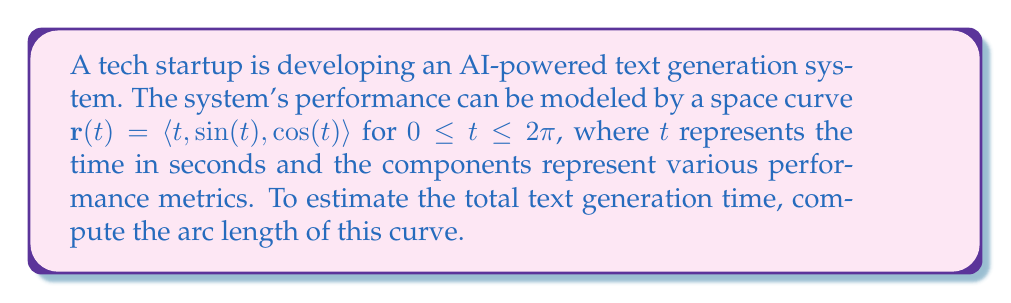Provide a solution to this math problem. To find the arc length of a space curve, we use the formula:

$$L = \int_a^b \sqrt{\left(\frac{dx}{dt}\right)^2 + \left(\frac{dy}{dt}\right)^2 + \left(\frac{dz}{dt}\right)^2} dt$$

Where $\mathbf{r}(t) = \langle x(t), y(t), z(t) \rangle$.

For our curve $\mathbf{r}(t) = \langle t, \sin(t), \cos(t) \rangle$:

1) First, we find the derivatives:
   $\frac{dx}{dt} = 1$
   $\frac{dy}{dt} = \cos(t)$
   $\frac{dz}{dt} = -\sin(t)$

2) Substitute these into the arc length formula:

   $$L = \int_0^{2\pi} \sqrt{1^2 + (\cos(t))^2 + (-\sin(t))^2} dt$$

3) Simplify under the square root:
   
   $$L = \int_0^{2\pi} \sqrt{1 + \cos^2(t) + \sin^2(t)} dt$$

4) Recall the trigonometric identity $\sin^2(t) + \cos^2(t) = 1$:

   $$L = \int_0^{2\pi} \sqrt{1 + 1} dt = \int_0^{2\pi} \sqrt{2} dt$$

5) $\sqrt{2}$ is a constant, so we can take it out of the integral:

   $$L = \sqrt{2} \int_0^{2\pi} dt$$

6) Evaluate the integral:

   $$L = \sqrt{2} [t]_0^{2\pi} = \sqrt{2} (2\pi - 0) = 2\pi\sqrt{2}$$

Therefore, the arc length of the curve, which estimates the total text generation time, is $2\pi\sqrt{2}$ seconds.
Answer: $2\pi\sqrt{2}$ seconds 